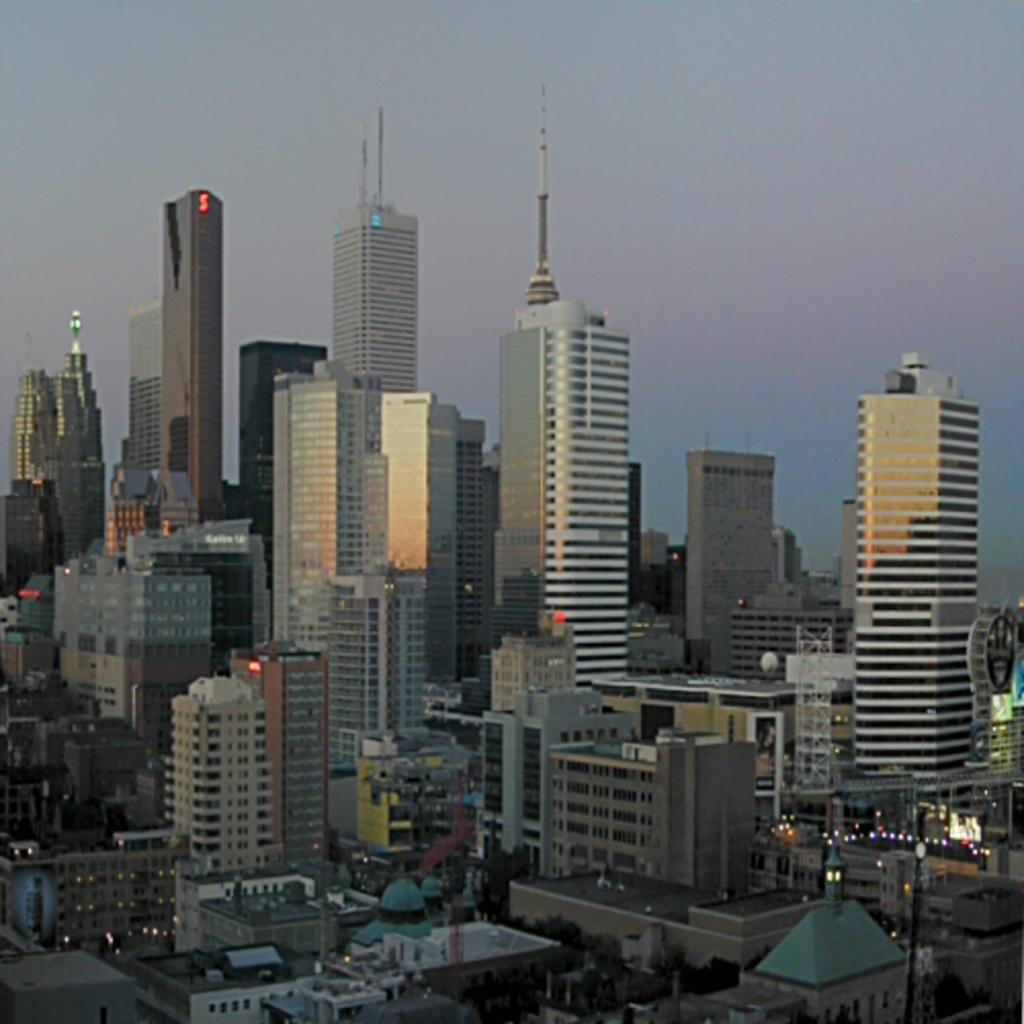What perspective is the image taken from? The image is taken from a top view. What type of structures can be seen in the image? There are buildings visible in the image. What else can be seen in the image besides buildings? There are lights visible in the image. What is visible at the top of the image? The sky is visible at the top of the image. What type of sweater is being worn by the building in the image? There are no people or clothing items present in the image, only buildings and lights. 